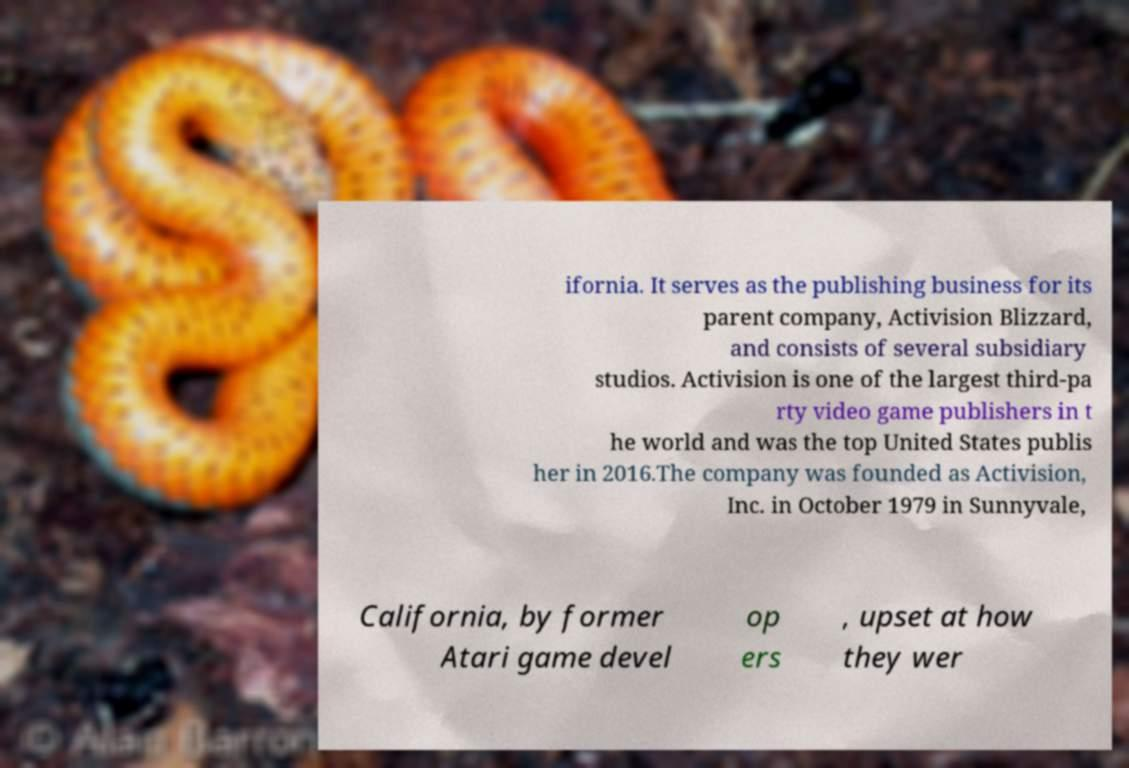Could you extract and type out the text from this image? ifornia. It serves as the publishing business for its parent company, Activision Blizzard, and consists of several subsidiary studios. Activision is one of the largest third-pa rty video game publishers in t he world and was the top United States publis her in 2016.The company was founded as Activision, Inc. in October 1979 in Sunnyvale, California, by former Atari game devel op ers , upset at how they wer 